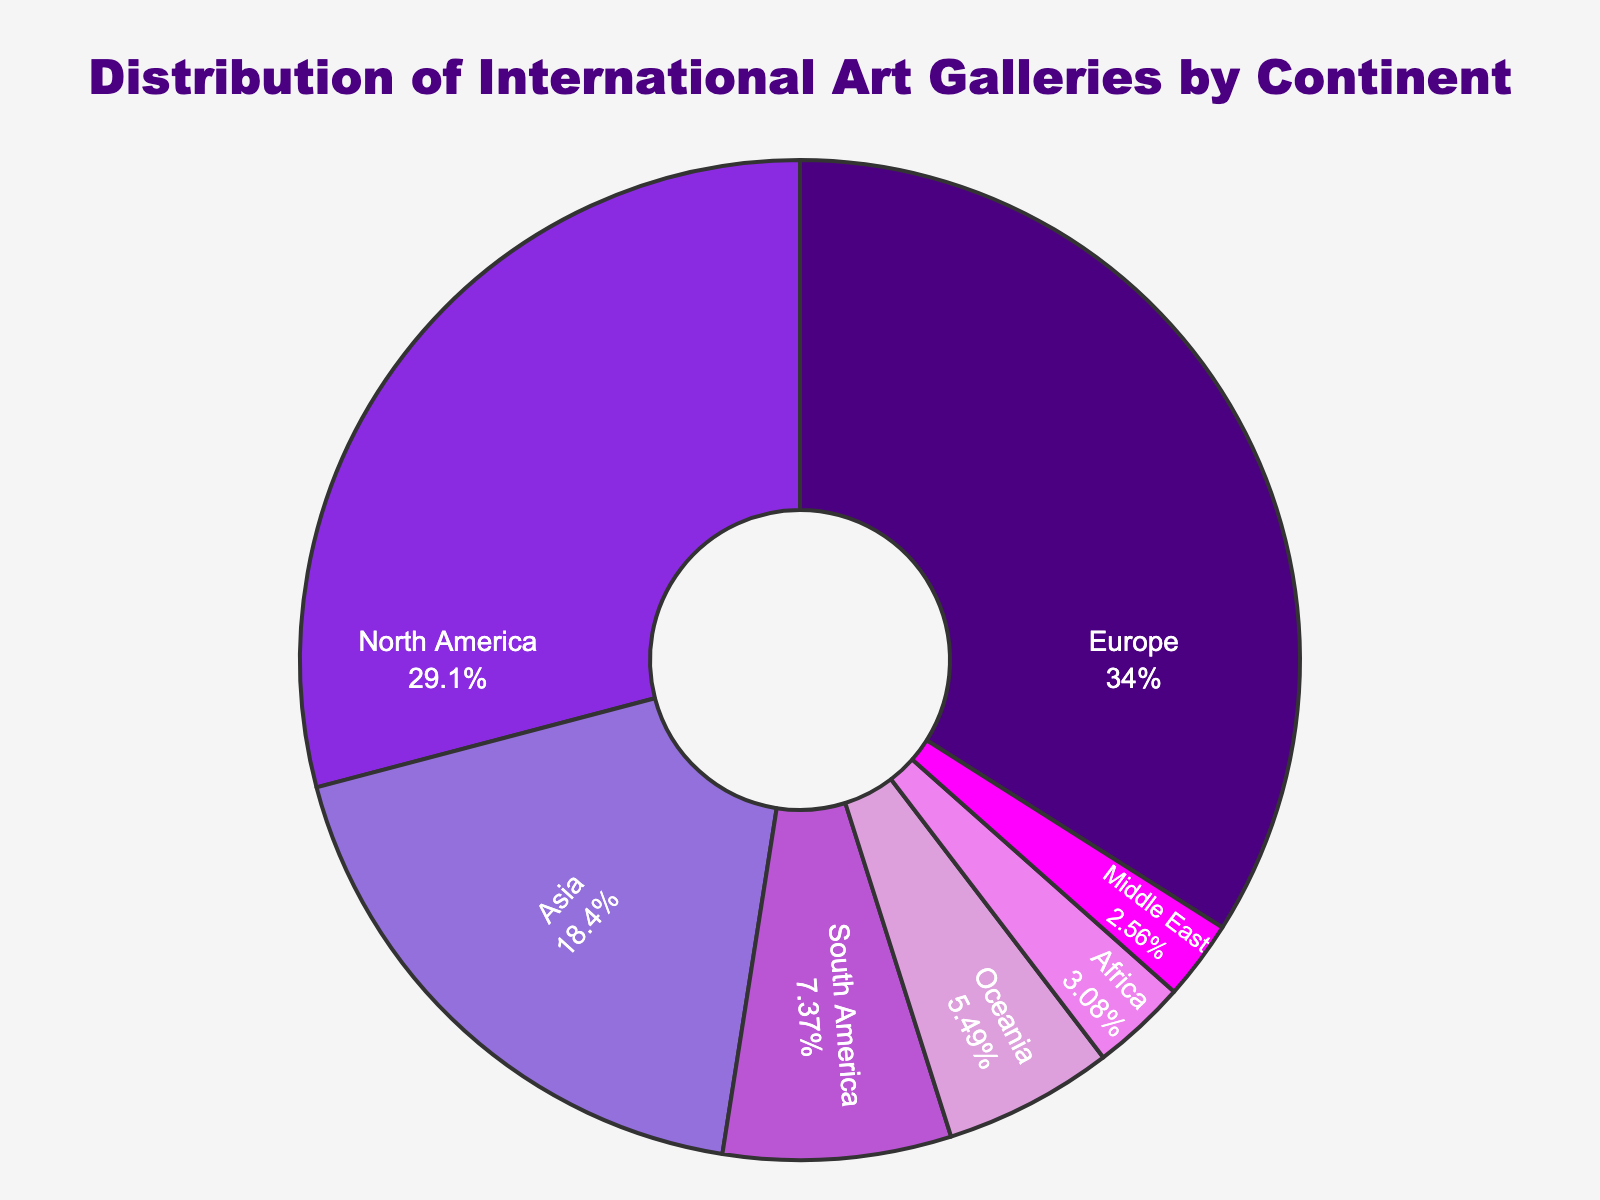What percentage of international art galleries are in Europe? By looking at the pie chart, see the section labeled 'Europe.' The text inside the section shows the percentage of international galleries in Europe.
Answer: 34% Which continent has the second-highest number of international galleries? By scanning the pie chart sections for size and checking the labels, North America has the next largest section after Europe.
Answer: North America How many more galleries does Europe have compared to Africa? To find the difference, look at the number of galleries in Europe (452) and Africa (41). Subtract the number of galleries in Africa from the number of galleries in Europe: 452 - 41 = 411.
Answer: 411 What is the total number of international galleries in Asia, South America, and Oceania combined? Add the number of galleries from each of these continents: Asia (245) + South America (98) + Oceania (73). 245 + 98 + 73 = 416.
Answer: 416 What continent has the smallest share of international art galleries, and what is its percentage? By identifying the smallest section in the pie chart, the Middle East has the smallest share. The percentage inside this section is 3%.
Answer: Middle East, 3% How does the number of galleries in North America compare to those in South America? Compare the numbers from the pie chart: North America has 387 galleries while South America has 98.
Answer: North America has more galleries Double the number of galleries in Oceania, and see if it is more than the number in Asia. Oceania has 73 galleries. Double this number: 73 * 2 = 146. Compare 146 with the number in Asia, which is 245.
Answer: No, it is not more Which continent's section is colored blue, and how many galleries does it represent? By observing the color of the sections, the continent with a blue section is Europe, which represents 452 galleries.
Answer: Europe, 452 Out of all the continents, which one has about a quarter the number of galleries as Europe? Calculate one-quarter of Europe's galleries: 452 * 0.25 = 113. Check the figure to find a continent with close to 113 galleries. The nearest is South America with 98 galleries.
Answer: South America 